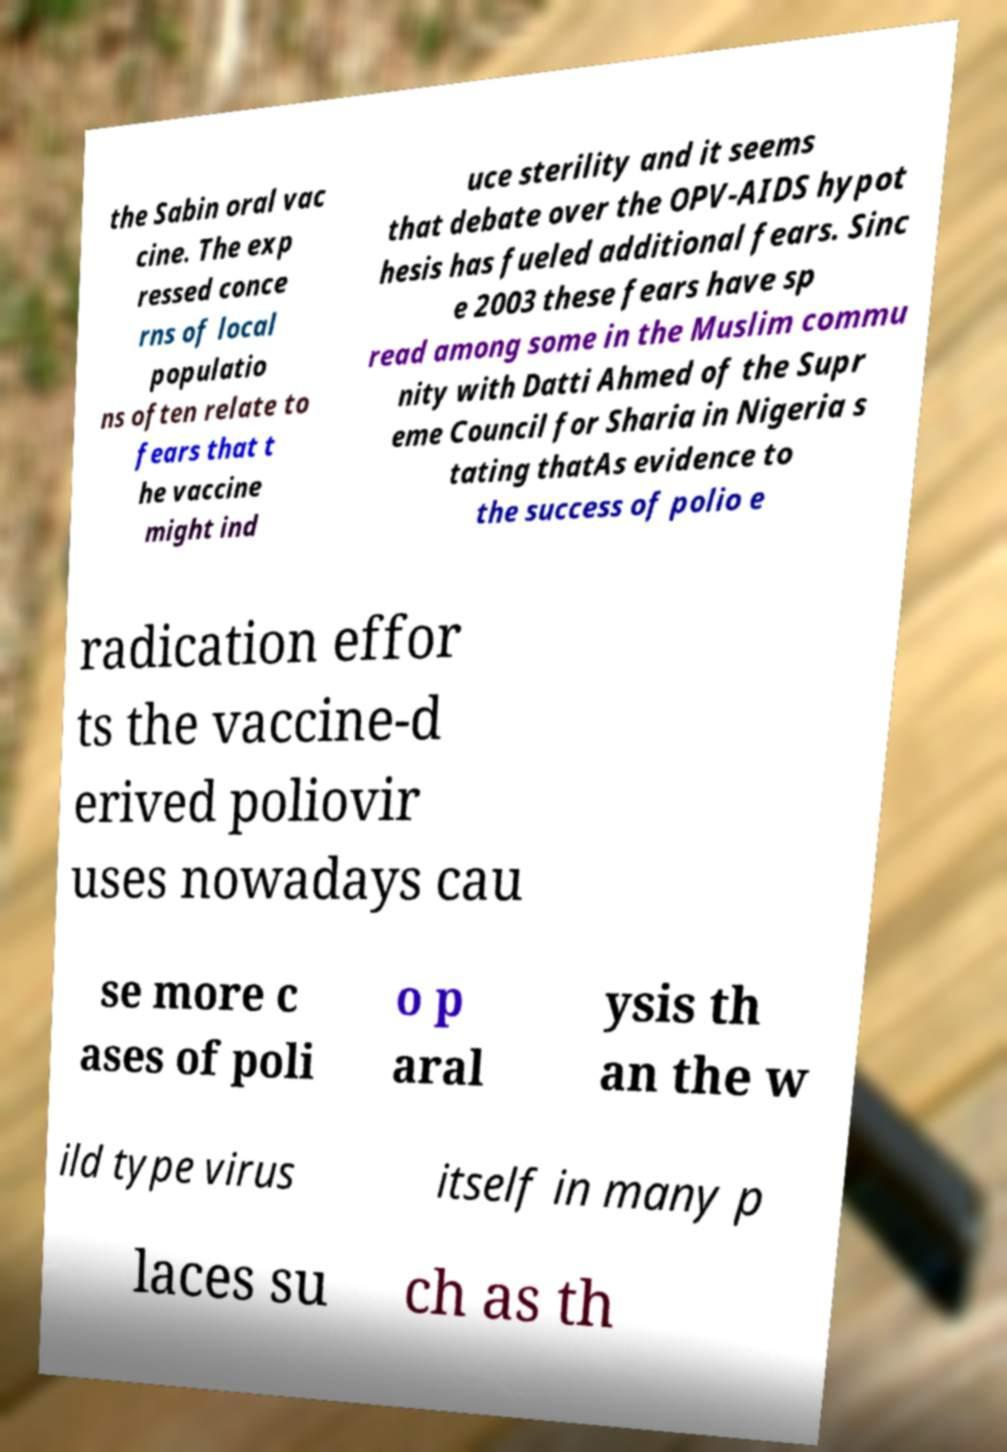Could you extract and type out the text from this image? the Sabin oral vac cine. The exp ressed conce rns of local populatio ns often relate to fears that t he vaccine might ind uce sterility and it seems that debate over the OPV-AIDS hypot hesis has fueled additional fears. Sinc e 2003 these fears have sp read among some in the Muslim commu nity with Datti Ahmed of the Supr eme Council for Sharia in Nigeria s tating thatAs evidence to the success of polio e radication effor ts the vaccine-d erived poliovir uses nowadays cau se more c ases of poli o p aral ysis th an the w ild type virus itself in many p laces su ch as th 